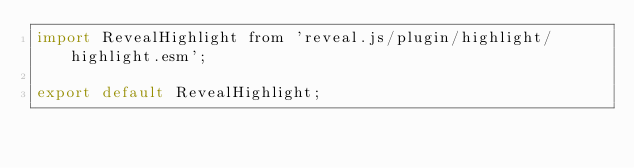Convert code to text. <code><loc_0><loc_0><loc_500><loc_500><_JavaScript_>import RevealHighlight from 'reveal.js/plugin/highlight/highlight.esm';

export default RevealHighlight;
</code> 